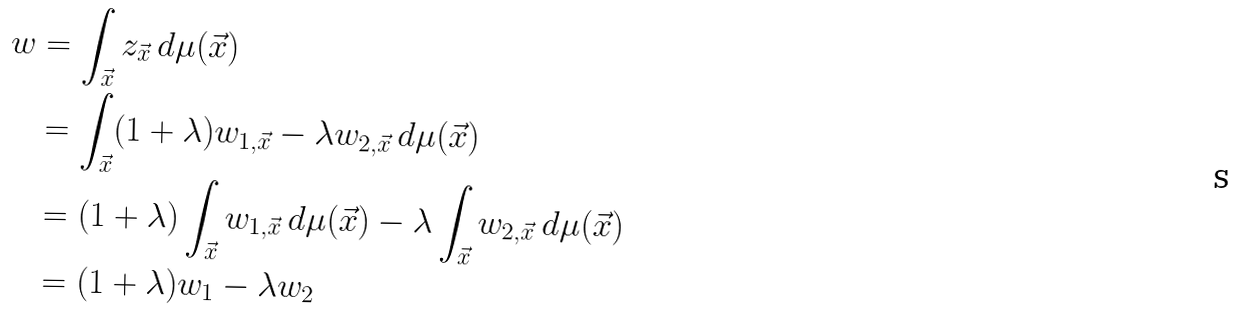Convert formula to latex. <formula><loc_0><loc_0><loc_500><loc_500>w & = \int _ { \vec { x } } z _ { \vec { x } } \, d \mu ( \vec { x } ) \\ & = \int _ { \vec { x } } ( 1 + \lambda ) w _ { 1 , \vec { x } } - \lambda w _ { 2 , \vec { x } } \, d \mu ( \vec { x } ) \\ & = ( 1 + \lambda ) \int _ { \vec { x } } w _ { 1 , \vec { x } } \, d \mu ( \vec { x } ) - \lambda \int _ { \vec { x } } w _ { 2 , \vec { x } } \, d \mu ( \vec { x } ) \\ & = ( 1 + \lambda ) w _ { 1 } - \lambda w _ { 2 }</formula> 